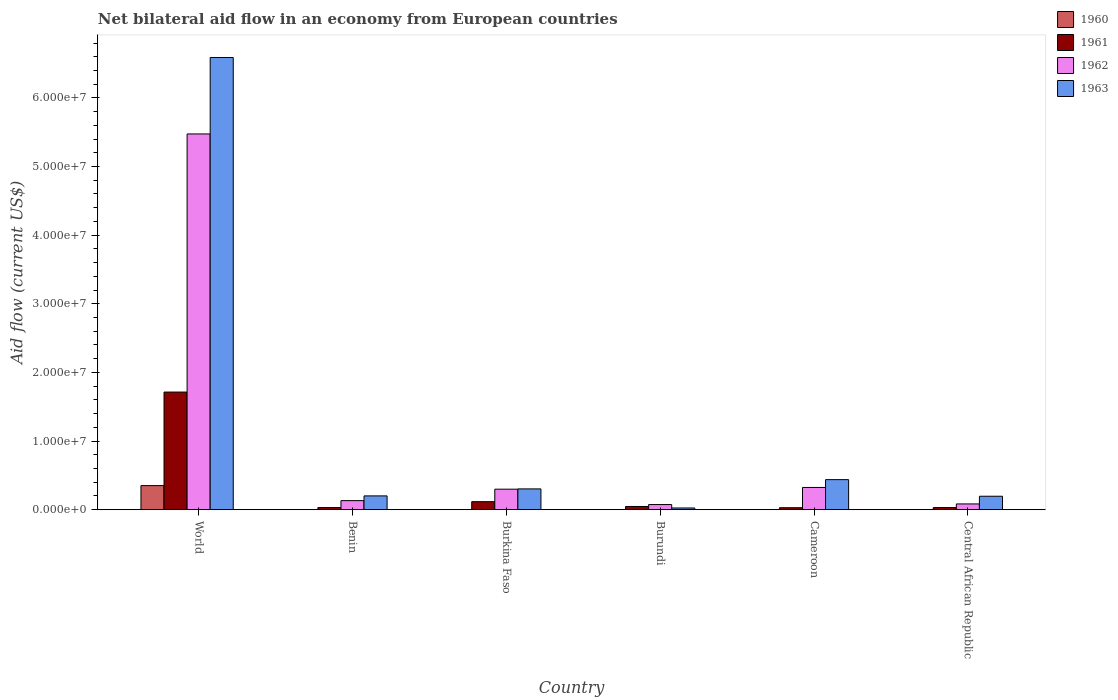How many groups of bars are there?
Give a very brief answer. 6. Are the number of bars per tick equal to the number of legend labels?
Offer a very short reply. Yes. Are the number of bars on each tick of the X-axis equal?
Your answer should be very brief. Yes. What is the label of the 6th group of bars from the left?
Your answer should be compact. Central African Republic. What is the net bilateral aid flow in 1963 in Burkina Faso?
Ensure brevity in your answer.  3.03e+06. Across all countries, what is the maximum net bilateral aid flow in 1963?
Provide a succinct answer. 6.59e+07. Across all countries, what is the minimum net bilateral aid flow in 1963?
Give a very brief answer. 2.50e+05. In which country was the net bilateral aid flow in 1960 minimum?
Offer a very short reply. Benin. What is the total net bilateral aid flow in 1962 in the graph?
Provide a short and direct response. 6.39e+07. What is the difference between the net bilateral aid flow in 1963 in Cameroon and that in Central African Republic?
Offer a very short reply. 2.42e+06. What is the difference between the net bilateral aid flow in 1961 in Cameroon and the net bilateral aid flow in 1963 in Central African Republic?
Your answer should be very brief. -1.67e+06. What is the average net bilateral aid flow in 1960 per country?
Your response must be concise. 5.97e+05. In how many countries, is the net bilateral aid flow in 1960 greater than 66000000 US$?
Provide a short and direct response. 0. Is the net bilateral aid flow in 1963 in Burkina Faso less than that in Central African Republic?
Your answer should be compact. No. What is the difference between the highest and the second highest net bilateral aid flow in 1963?
Offer a very short reply. 6.15e+07. What is the difference between the highest and the lowest net bilateral aid flow in 1960?
Give a very brief answer. 3.50e+06. Is the sum of the net bilateral aid flow in 1960 in Cameroon and Central African Republic greater than the maximum net bilateral aid flow in 1961 across all countries?
Your response must be concise. No. Is it the case that in every country, the sum of the net bilateral aid flow in 1963 and net bilateral aid flow in 1961 is greater than the sum of net bilateral aid flow in 1962 and net bilateral aid flow in 1960?
Provide a succinct answer. No. What is the difference between two consecutive major ticks on the Y-axis?
Your answer should be compact. 1.00e+07. Are the values on the major ticks of Y-axis written in scientific E-notation?
Your answer should be compact. Yes. Does the graph contain grids?
Your answer should be compact. No. Where does the legend appear in the graph?
Keep it short and to the point. Top right. How many legend labels are there?
Your answer should be compact. 4. How are the legend labels stacked?
Your response must be concise. Vertical. What is the title of the graph?
Ensure brevity in your answer.  Net bilateral aid flow in an economy from European countries. Does "1963" appear as one of the legend labels in the graph?
Keep it short and to the point. Yes. What is the label or title of the X-axis?
Offer a terse response. Country. What is the label or title of the Y-axis?
Ensure brevity in your answer.  Aid flow (current US$). What is the Aid flow (current US$) in 1960 in World?
Your answer should be compact. 3.51e+06. What is the Aid flow (current US$) in 1961 in World?
Provide a short and direct response. 1.71e+07. What is the Aid flow (current US$) in 1962 in World?
Ensure brevity in your answer.  5.48e+07. What is the Aid flow (current US$) in 1963 in World?
Provide a succinct answer. 6.59e+07. What is the Aid flow (current US$) of 1960 in Benin?
Provide a short and direct response. 10000. What is the Aid flow (current US$) in 1961 in Benin?
Offer a very short reply. 3.10e+05. What is the Aid flow (current US$) of 1962 in Benin?
Offer a very short reply. 1.32e+06. What is the Aid flow (current US$) in 1963 in Benin?
Offer a terse response. 2.01e+06. What is the Aid flow (current US$) in 1960 in Burkina Faso?
Offer a very short reply. 10000. What is the Aid flow (current US$) in 1961 in Burkina Faso?
Keep it short and to the point. 1.17e+06. What is the Aid flow (current US$) of 1962 in Burkina Faso?
Ensure brevity in your answer.  2.99e+06. What is the Aid flow (current US$) in 1963 in Burkina Faso?
Your response must be concise. 3.03e+06. What is the Aid flow (current US$) in 1961 in Burundi?
Make the answer very short. 4.70e+05. What is the Aid flow (current US$) in 1962 in Burundi?
Your response must be concise. 7.50e+05. What is the Aid flow (current US$) of 1963 in Burundi?
Provide a short and direct response. 2.50e+05. What is the Aid flow (current US$) in 1960 in Cameroon?
Keep it short and to the point. 2.00e+04. What is the Aid flow (current US$) of 1962 in Cameroon?
Give a very brief answer. 3.24e+06. What is the Aid flow (current US$) in 1963 in Cameroon?
Make the answer very short. 4.38e+06. What is the Aid flow (current US$) of 1961 in Central African Republic?
Ensure brevity in your answer.  3.10e+05. What is the Aid flow (current US$) of 1962 in Central African Republic?
Your response must be concise. 8.40e+05. What is the Aid flow (current US$) in 1963 in Central African Republic?
Your response must be concise. 1.96e+06. Across all countries, what is the maximum Aid flow (current US$) in 1960?
Your answer should be very brief. 3.51e+06. Across all countries, what is the maximum Aid flow (current US$) in 1961?
Your answer should be very brief. 1.71e+07. Across all countries, what is the maximum Aid flow (current US$) in 1962?
Offer a terse response. 5.48e+07. Across all countries, what is the maximum Aid flow (current US$) of 1963?
Make the answer very short. 6.59e+07. Across all countries, what is the minimum Aid flow (current US$) in 1960?
Provide a succinct answer. 10000. Across all countries, what is the minimum Aid flow (current US$) in 1961?
Your response must be concise. 2.90e+05. Across all countries, what is the minimum Aid flow (current US$) of 1962?
Your answer should be very brief. 7.50e+05. Across all countries, what is the minimum Aid flow (current US$) in 1963?
Provide a succinct answer. 2.50e+05. What is the total Aid flow (current US$) in 1960 in the graph?
Give a very brief answer. 3.58e+06. What is the total Aid flow (current US$) in 1961 in the graph?
Your answer should be very brief. 1.97e+07. What is the total Aid flow (current US$) in 1962 in the graph?
Ensure brevity in your answer.  6.39e+07. What is the total Aid flow (current US$) of 1963 in the graph?
Your response must be concise. 7.75e+07. What is the difference between the Aid flow (current US$) of 1960 in World and that in Benin?
Offer a terse response. 3.50e+06. What is the difference between the Aid flow (current US$) of 1961 in World and that in Benin?
Your response must be concise. 1.68e+07. What is the difference between the Aid flow (current US$) of 1962 in World and that in Benin?
Offer a very short reply. 5.34e+07. What is the difference between the Aid flow (current US$) of 1963 in World and that in Benin?
Provide a short and direct response. 6.39e+07. What is the difference between the Aid flow (current US$) in 1960 in World and that in Burkina Faso?
Provide a succinct answer. 3.50e+06. What is the difference between the Aid flow (current US$) in 1961 in World and that in Burkina Faso?
Ensure brevity in your answer.  1.60e+07. What is the difference between the Aid flow (current US$) in 1962 in World and that in Burkina Faso?
Ensure brevity in your answer.  5.18e+07. What is the difference between the Aid flow (current US$) in 1963 in World and that in Burkina Faso?
Your response must be concise. 6.29e+07. What is the difference between the Aid flow (current US$) in 1960 in World and that in Burundi?
Offer a terse response. 3.50e+06. What is the difference between the Aid flow (current US$) of 1961 in World and that in Burundi?
Ensure brevity in your answer.  1.67e+07. What is the difference between the Aid flow (current US$) in 1962 in World and that in Burundi?
Make the answer very short. 5.40e+07. What is the difference between the Aid flow (current US$) in 1963 in World and that in Burundi?
Offer a very short reply. 6.56e+07. What is the difference between the Aid flow (current US$) in 1960 in World and that in Cameroon?
Keep it short and to the point. 3.49e+06. What is the difference between the Aid flow (current US$) of 1961 in World and that in Cameroon?
Keep it short and to the point. 1.68e+07. What is the difference between the Aid flow (current US$) in 1962 in World and that in Cameroon?
Offer a very short reply. 5.15e+07. What is the difference between the Aid flow (current US$) of 1963 in World and that in Cameroon?
Offer a terse response. 6.15e+07. What is the difference between the Aid flow (current US$) of 1960 in World and that in Central African Republic?
Your response must be concise. 3.49e+06. What is the difference between the Aid flow (current US$) of 1961 in World and that in Central African Republic?
Your answer should be compact. 1.68e+07. What is the difference between the Aid flow (current US$) in 1962 in World and that in Central African Republic?
Offer a terse response. 5.39e+07. What is the difference between the Aid flow (current US$) in 1963 in World and that in Central African Republic?
Your response must be concise. 6.39e+07. What is the difference between the Aid flow (current US$) in 1961 in Benin and that in Burkina Faso?
Your response must be concise. -8.60e+05. What is the difference between the Aid flow (current US$) in 1962 in Benin and that in Burkina Faso?
Provide a short and direct response. -1.67e+06. What is the difference between the Aid flow (current US$) of 1963 in Benin and that in Burkina Faso?
Make the answer very short. -1.02e+06. What is the difference between the Aid flow (current US$) in 1960 in Benin and that in Burundi?
Your answer should be compact. 0. What is the difference between the Aid flow (current US$) of 1962 in Benin and that in Burundi?
Ensure brevity in your answer.  5.70e+05. What is the difference between the Aid flow (current US$) in 1963 in Benin and that in Burundi?
Offer a terse response. 1.76e+06. What is the difference between the Aid flow (current US$) in 1960 in Benin and that in Cameroon?
Make the answer very short. -10000. What is the difference between the Aid flow (current US$) in 1962 in Benin and that in Cameroon?
Offer a very short reply. -1.92e+06. What is the difference between the Aid flow (current US$) of 1963 in Benin and that in Cameroon?
Offer a terse response. -2.37e+06. What is the difference between the Aid flow (current US$) of 1960 in Burkina Faso and that in Burundi?
Your answer should be compact. 0. What is the difference between the Aid flow (current US$) of 1962 in Burkina Faso and that in Burundi?
Your answer should be very brief. 2.24e+06. What is the difference between the Aid flow (current US$) of 1963 in Burkina Faso and that in Burundi?
Keep it short and to the point. 2.78e+06. What is the difference between the Aid flow (current US$) in 1961 in Burkina Faso and that in Cameroon?
Provide a succinct answer. 8.80e+05. What is the difference between the Aid flow (current US$) of 1963 in Burkina Faso and that in Cameroon?
Offer a very short reply. -1.35e+06. What is the difference between the Aid flow (current US$) of 1961 in Burkina Faso and that in Central African Republic?
Provide a short and direct response. 8.60e+05. What is the difference between the Aid flow (current US$) in 1962 in Burkina Faso and that in Central African Republic?
Offer a very short reply. 2.15e+06. What is the difference between the Aid flow (current US$) in 1963 in Burkina Faso and that in Central African Republic?
Offer a terse response. 1.07e+06. What is the difference between the Aid flow (current US$) of 1960 in Burundi and that in Cameroon?
Your response must be concise. -10000. What is the difference between the Aid flow (current US$) in 1961 in Burundi and that in Cameroon?
Provide a succinct answer. 1.80e+05. What is the difference between the Aid flow (current US$) of 1962 in Burundi and that in Cameroon?
Offer a terse response. -2.49e+06. What is the difference between the Aid flow (current US$) of 1963 in Burundi and that in Cameroon?
Offer a terse response. -4.13e+06. What is the difference between the Aid flow (current US$) in 1960 in Burundi and that in Central African Republic?
Your answer should be very brief. -10000. What is the difference between the Aid flow (current US$) in 1961 in Burundi and that in Central African Republic?
Offer a very short reply. 1.60e+05. What is the difference between the Aid flow (current US$) of 1963 in Burundi and that in Central African Republic?
Make the answer very short. -1.71e+06. What is the difference between the Aid flow (current US$) of 1961 in Cameroon and that in Central African Republic?
Your answer should be very brief. -2.00e+04. What is the difference between the Aid flow (current US$) in 1962 in Cameroon and that in Central African Republic?
Provide a short and direct response. 2.40e+06. What is the difference between the Aid flow (current US$) of 1963 in Cameroon and that in Central African Republic?
Your answer should be very brief. 2.42e+06. What is the difference between the Aid flow (current US$) of 1960 in World and the Aid flow (current US$) of 1961 in Benin?
Keep it short and to the point. 3.20e+06. What is the difference between the Aid flow (current US$) in 1960 in World and the Aid flow (current US$) in 1962 in Benin?
Give a very brief answer. 2.19e+06. What is the difference between the Aid flow (current US$) in 1960 in World and the Aid flow (current US$) in 1963 in Benin?
Your answer should be very brief. 1.50e+06. What is the difference between the Aid flow (current US$) in 1961 in World and the Aid flow (current US$) in 1962 in Benin?
Your answer should be very brief. 1.58e+07. What is the difference between the Aid flow (current US$) of 1961 in World and the Aid flow (current US$) of 1963 in Benin?
Make the answer very short. 1.51e+07. What is the difference between the Aid flow (current US$) of 1962 in World and the Aid flow (current US$) of 1963 in Benin?
Your answer should be compact. 5.27e+07. What is the difference between the Aid flow (current US$) in 1960 in World and the Aid flow (current US$) in 1961 in Burkina Faso?
Your answer should be compact. 2.34e+06. What is the difference between the Aid flow (current US$) in 1960 in World and the Aid flow (current US$) in 1962 in Burkina Faso?
Make the answer very short. 5.20e+05. What is the difference between the Aid flow (current US$) in 1961 in World and the Aid flow (current US$) in 1962 in Burkina Faso?
Offer a very short reply. 1.42e+07. What is the difference between the Aid flow (current US$) of 1961 in World and the Aid flow (current US$) of 1963 in Burkina Faso?
Make the answer very short. 1.41e+07. What is the difference between the Aid flow (current US$) of 1962 in World and the Aid flow (current US$) of 1963 in Burkina Faso?
Make the answer very short. 5.17e+07. What is the difference between the Aid flow (current US$) in 1960 in World and the Aid flow (current US$) in 1961 in Burundi?
Keep it short and to the point. 3.04e+06. What is the difference between the Aid flow (current US$) of 1960 in World and the Aid flow (current US$) of 1962 in Burundi?
Provide a short and direct response. 2.76e+06. What is the difference between the Aid flow (current US$) in 1960 in World and the Aid flow (current US$) in 1963 in Burundi?
Ensure brevity in your answer.  3.26e+06. What is the difference between the Aid flow (current US$) in 1961 in World and the Aid flow (current US$) in 1962 in Burundi?
Offer a very short reply. 1.64e+07. What is the difference between the Aid flow (current US$) of 1961 in World and the Aid flow (current US$) of 1963 in Burundi?
Your response must be concise. 1.69e+07. What is the difference between the Aid flow (current US$) of 1962 in World and the Aid flow (current US$) of 1963 in Burundi?
Your response must be concise. 5.45e+07. What is the difference between the Aid flow (current US$) in 1960 in World and the Aid flow (current US$) in 1961 in Cameroon?
Make the answer very short. 3.22e+06. What is the difference between the Aid flow (current US$) of 1960 in World and the Aid flow (current US$) of 1962 in Cameroon?
Provide a succinct answer. 2.70e+05. What is the difference between the Aid flow (current US$) in 1960 in World and the Aid flow (current US$) in 1963 in Cameroon?
Offer a terse response. -8.70e+05. What is the difference between the Aid flow (current US$) in 1961 in World and the Aid flow (current US$) in 1962 in Cameroon?
Your response must be concise. 1.39e+07. What is the difference between the Aid flow (current US$) of 1961 in World and the Aid flow (current US$) of 1963 in Cameroon?
Keep it short and to the point. 1.28e+07. What is the difference between the Aid flow (current US$) in 1962 in World and the Aid flow (current US$) in 1963 in Cameroon?
Ensure brevity in your answer.  5.04e+07. What is the difference between the Aid flow (current US$) in 1960 in World and the Aid flow (current US$) in 1961 in Central African Republic?
Offer a very short reply. 3.20e+06. What is the difference between the Aid flow (current US$) of 1960 in World and the Aid flow (current US$) of 1962 in Central African Republic?
Offer a terse response. 2.67e+06. What is the difference between the Aid flow (current US$) of 1960 in World and the Aid flow (current US$) of 1963 in Central African Republic?
Your response must be concise. 1.55e+06. What is the difference between the Aid flow (current US$) of 1961 in World and the Aid flow (current US$) of 1962 in Central African Republic?
Provide a succinct answer. 1.63e+07. What is the difference between the Aid flow (current US$) in 1961 in World and the Aid flow (current US$) in 1963 in Central African Republic?
Offer a very short reply. 1.52e+07. What is the difference between the Aid flow (current US$) in 1962 in World and the Aid flow (current US$) in 1963 in Central African Republic?
Offer a very short reply. 5.28e+07. What is the difference between the Aid flow (current US$) in 1960 in Benin and the Aid flow (current US$) in 1961 in Burkina Faso?
Your answer should be compact. -1.16e+06. What is the difference between the Aid flow (current US$) in 1960 in Benin and the Aid flow (current US$) in 1962 in Burkina Faso?
Your answer should be compact. -2.98e+06. What is the difference between the Aid flow (current US$) in 1960 in Benin and the Aid flow (current US$) in 1963 in Burkina Faso?
Your answer should be compact. -3.02e+06. What is the difference between the Aid flow (current US$) of 1961 in Benin and the Aid flow (current US$) of 1962 in Burkina Faso?
Keep it short and to the point. -2.68e+06. What is the difference between the Aid flow (current US$) in 1961 in Benin and the Aid flow (current US$) in 1963 in Burkina Faso?
Offer a very short reply. -2.72e+06. What is the difference between the Aid flow (current US$) in 1962 in Benin and the Aid flow (current US$) in 1963 in Burkina Faso?
Your answer should be very brief. -1.71e+06. What is the difference between the Aid flow (current US$) of 1960 in Benin and the Aid flow (current US$) of 1961 in Burundi?
Your answer should be compact. -4.60e+05. What is the difference between the Aid flow (current US$) of 1960 in Benin and the Aid flow (current US$) of 1962 in Burundi?
Keep it short and to the point. -7.40e+05. What is the difference between the Aid flow (current US$) in 1961 in Benin and the Aid flow (current US$) in 1962 in Burundi?
Provide a succinct answer. -4.40e+05. What is the difference between the Aid flow (current US$) in 1962 in Benin and the Aid flow (current US$) in 1963 in Burundi?
Give a very brief answer. 1.07e+06. What is the difference between the Aid flow (current US$) of 1960 in Benin and the Aid flow (current US$) of 1961 in Cameroon?
Ensure brevity in your answer.  -2.80e+05. What is the difference between the Aid flow (current US$) of 1960 in Benin and the Aid flow (current US$) of 1962 in Cameroon?
Keep it short and to the point. -3.23e+06. What is the difference between the Aid flow (current US$) in 1960 in Benin and the Aid flow (current US$) in 1963 in Cameroon?
Give a very brief answer. -4.37e+06. What is the difference between the Aid flow (current US$) in 1961 in Benin and the Aid flow (current US$) in 1962 in Cameroon?
Offer a terse response. -2.93e+06. What is the difference between the Aid flow (current US$) in 1961 in Benin and the Aid flow (current US$) in 1963 in Cameroon?
Give a very brief answer. -4.07e+06. What is the difference between the Aid flow (current US$) in 1962 in Benin and the Aid flow (current US$) in 1963 in Cameroon?
Your response must be concise. -3.06e+06. What is the difference between the Aid flow (current US$) of 1960 in Benin and the Aid flow (current US$) of 1962 in Central African Republic?
Provide a short and direct response. -8.30e+05. What is the difference between the Aid flow (current US$) of 1960 in Benin and the Aid flow (current US$) of 1963 in Central African Republic?
Your answer should be very brief. -1.95e+06. What is the difference between the Aid flow (current US$) of 1961 in Benin and the Aid flow (current US$) of 1962 in Central African Republic?
Your response must be concise. -5.30e+05. What is the difference between the Aid flow (current US$) in 1961 in Benin and the Aid flow (current US$) in 1963 in Central African Republic?
Provide a succinct answer. -1.65e+06. What is the difference between the Aid flow (current US$) in 1962 in Benin and the Aid flow (current US$) in 1963 in Central African Republic?
Your answer should be compact. -6.40e+05. What is the difference between the Aid flow (current US$) in 1960 in Burkina Faso and the Aid flow (current US$) in 1961 in Burundi?
Offer a terse response. -4.60e+05. What is the difference between the Aid flow (current US$) of 1960 in Burkina Faso and the Aid flow (current US$) of 1962 in Burundi?
Offer a terse response. -7.40e+05. What is the difference between the Aid flow (current US$) in 1960 in Burkina Faso and the Aid flow (current US$) in 1963 in Burundi?
Ensure brevity in your answer.  -2.40e+05. What is the difference between the Aid flow (current US$) of 1961 in Burkina Faso and the Aid flow (current US$) of 1963 in Burundi?
Offer a terse response. 9.20e+05. What is the difference between the Aid flow (current US$) of 1962 in Burkina Faso and the Aid flow (current US$) of 1963 in Burundi?
Offer a very short reply. 2.74e+06. What is the difference between the Aid flow (current US$) in 1960 in Burkina Faso and the Aid flow (current US$) in 1961 in Cameroon?
Your response must be concise. -2.80e+05. What is the difference between the Aid flow (current US$) in 1960 in Burkina Faso and the Aid flow (current US$) in 1962 in Cameroon?
Provide a short and direct response. -3.23e+06. What is the difference between the Aid flow (current US$) of 1960 in Burkina Faso and the Aid flow (current US$) of 1963 in Cameroon?
Ensure brevity in your answer.  -4.37e+06. What is the difference between the Aid flow (current US$) of 1961 in Burkina Faso and the Aid flow (current US$) of 1962 in Cameroon?
Make the answer very short. -2.07e+06. What is the difference between the Aid flow (current US$) of 1961 in Burkina Faso and the Aid flow (current US$) of 1963 in Cameroon?
Give a very brief answer. -3.21e+06. What is the difference between the Aid flow (current US$) in 1962 in Burkina Faso and the Aid flow (current US$) in 1963 in Cameroon?
Keep it short and to the point. -1.39e+06. What is the difference between the Aid flow (current US$) in 1960 in Burkina Faso and the Aid flow (current US$) in 1961 in Central African Republic?
Give a very brief answer. -3.00e+05. What is the difference between the Aid flow (current US$) in 1960 in Burkina Faso and the Aid flow (current US$) in 1962 in Central African Republic?
Keep it short and to the point. -8.30e+05. What is the difference between the Aid flow (current US$) of 1960 in Burkina Faso and the Aid flow (current US$) of 1963 in Central African Republic?
Offer a terse response. -1.95e+06. What is the difference between the Aid flow (current US$) of 1961 in Burkina Faso and the Aid flow (current US$) of 1963 in Central African Republic?
Ensure brevity in your answer.  -7.90e+05. What is the difference between the Aid flow (current US$) of 1962 in Burkina Faso and the Aid flow (current US$) of 1963 in Central African Republic?
Offer a terse response. 1.03e+06. What is the difference between the Aid flow (current US$) of 1960 in Burundi and the Aid flow (current US$) of 1961 in Cameroon?
Your answer should be very brief. -2.80e+05. What is the difference between the Aid flow (current US$) in 1960 in Burundi and the Aid flow (current US$) in 1962 in Cameroon?
Keep it short and to the point. -3.23e+06. What is the difference between the Aid flow (current US$) of 1960 in Burundi and the Aid flow (current US$) of 1963 in Cameroon?
Your answer should be compact. -4.37e+06. What is the difference between the Aid flow (current US$) in 1961 in Burundi and the Aid flow (current US$) in 1962 in Cameroon?
Offer a terse response. -2.77e+06. What is the difference between the Aid flow (current US$) in 1961 in Burundi and the Aid flow (current US$) in 1963 in Cameroon?
Provide a succinct answer. -3.91e+06. What is the difference between the Aid flow (current US$) in 1962 in Burundi and the Aid flow (current US$) in 1963 in Cameroon?
Make the answer very short. -3.63e+06. What is the difference between the Aid flow (current US$) in 1960 in Burundi and the Aid flow (current US$) in 1962 in Central African Republic?
Offer a very short reply. -8.30e+05. What is the difference between the Aid flow (current US$) of 1960 in Burundi and the Aid flow (current US$) of 1963 in Central African Republic?
Provide a succinct answer. -1.95e+06. What is the difference between the Aid flow (current US$) in 1961 in Burundi and the Aid flow (current US$) in 1962 in Central African Republic?
Your answer should be compact. -3.70e+05. What is the difference between the Aid flow (current US$) of 1961 in Burundi and the Aid flow (current US$) of 1963 in Central African Republic?
Your answer should be very brief. -1.49e+06. What is the difference between the Aid flow (current US$) in 1962 in Burundi and the Aid flow (current US$) in 1963 in Central African Republic?
Keep it short and to the point. -1.21e+06. What is the difference between the Aid flow (current US$) in 1960 in Cameroon and the Aid flow (current US$) in 1962 in Central African Republic?
Offer a terse response. -8.20e+05. What is the difference between the Aid flow (current US$) in 1960 in Cameroon and the Aid flow (current US$) in 1963 in Central African Republic?
Your answer should be compact. -1.94e+06. What is the difference between the Aid flow (current US$) in 1961 in Cameroon and the Aid flow (current US$) in 1962 in Central African Republic?
Offer a very short reply. -5.50e+05. What is the difference between the Aid flow (current US$) of 1961 in Cameroon and the Aid flow (current US$) of 1963 in Central African Republic?
Your response must be concise. -1.67e+06. What is the difference between the Aid flow (current US$) in 1962 in Cameroon and the Aid flow (current US$) in 1963 in Central African Republic?
Your response must be concise. 1.28e+06. What is the average Aid flow (current US$) of 1960 per country?
Keep it short and to the point. 5.97e+05. What is the average Aid flow (current US$) of 1961 per country?
Your response must be concise. 3.28e+06. What is the average Aid flow (current US$) in 1962 per country?
Your answer should be very brief. 1.06e+07. What is the average Aid flow (current US$) in 1963 per country?
Provide a succinct answer. 1.29e+07. What is the difference between the Aid flow (current US$) in 1960 and Aid flow (current US$) in 1961 in World?
Your answer should be very brief. -1.36e+07. What is the difference between the Aid flow (current US$) in 1960 and Aid flow (current US$) in 1962 in World?
Your answer should be compact. -5.12e+07. What is the difference between the Aid flow (current US$) of 1960 and Aid flow (current US$) of 1963 in World?
Keep it short and to the point. -6.24e+07. What is the difference between the Aid flow (current US$) of 1961 and Aid flow (current US$) of 1962 in World?
Your response must be concise. -3.76e+07. What is the difference between the Aid flow (current US$) of 1961 and Aid flow (current US$) of 1963 in World?
Provide a succinct answer. -4.88e+07. What is the difference between the Aid flow (current US$) in 1962 and Aid flow (current US$) in 1963 in World?
Offer a very short reply. -1.11e+07. What is the difference between the Aid flow (current US$) in 1960 and Aid flow (current US$) in 1961 in Benin?
Your answer should be very brief. -3.00e+05. What is the difference between the Aid flow (current US$) of 1960 and Aid flow (current US$) of 1962 in Benin?
Your response must be concise. -1.31e+06. What is the difference between the Aid flow (current US$) in 1961 and Aid flow (current US$) in 1962 in Benin?
Offer a very short reply. -1.01e+06. What is the difference between the Aid flow (current US$) of 1961 and Aid flow (current US$) of 1963 in Benin?
Ensure brevity in your answer.  -1.70e+06. What is the difference between the Aid flow (current US$) of 1962 and Aid flow (current US$) of 1963 in Benin?
Offer a terse response. -6.90e+05. What is the difference between the Aid flow (current US$) of 1960 and Aid flow (current US$) of 1961 in Burkina Faso?
Provide a succinct answer. -1.16e+06. What is the difference between the Aid flow (current US$) in 1960 and Aid flow (current US$) in 1962 in Burkina Faso?
Make the answer very short. -2.98e+06. What is the difference between the Aid flow (current US$) in 1960 and Aid flow (current US$) in 1963 in Burkina Faso?
Make the answer very short. -3.02e+06. What is the difference between the Aid flow (current US$) of 1961 and Aid flow (current US$) of 1962 in Burkina Faso?
Your response must be concise. -1.82e+06. What is the difference between the Aid flow (current US$) of 1961 and Aid flow (current US$) of 1963 in Burkina Faso?
Ensure brevity in your answer.  -1.86e+06. What is the difference between the Aid flow (current US$) of 1960 and Aid flow (current US$) of 1961 in Burundi?
Offer a terse response. -4.60e+05. What is the difference between the Aid flow (current US$) of 1960 and Aid flow (current US$) of 1962 in Burundi?
Give a very brief answer. -7.40e+05. What is the difference between the Aid flow (current US$) of 1961 and Aid flow (current US$) of 1962 in Burundi?
Offer a terse response. -2.80e+05. What is the difference between the Aid flow (current US$) in 1961 and Aid flow (current US$) in 1963 in Burundi?
Provide a short and direct response. 2.20e+05. What is the difference between the Aid flow (current US$) of 1962 and Aid flow (current US$) of 1963 in Burundi?
Offer a very short reply. 5.00e+05. What is the difference between the Aid flow (current US$) in 1960 and Aid flow (current US$) in 1961 in Cameroon?
Provide a succinct answer. -2.70e+05. What is the difference between the Aid flow (current US$) in 1960 and Aid flow (current US$) in 1962 in Cameroon?
Your response must be concise. -3.22e+06. What is the difference between the Aid flow (current US$) in 1960 and Aid flow (current US$) in 1963 in Cameroon?
Keep it short and to the point. -4.36e+06. What is the difference between the Aid flow (current US$) in 1961 and Aid flow (current US$) in 1962 in Cameroon?
Keep it short and to the point. -2.95e+06. What is the difference between the Aid flow (current US$) in 1961 and Aid flow (current US$) in 1963 in Cameroon?
Make the answer very short. -4.09e+06. What is the difference between the Aid flow (current US$) of 1962 and Aid flow (current US$) of 1963 in Cameroon?
Offer a very short reply. -1.14e+06. What is the difference between the Aid flow (current US$) in 1960 and Aid flow (current US$) in 1961 in Central African Republic?
Offer a terse response. -2.90e+05. What is the difference between the Aid flow (current US$) in 1960 and Aid flow (current US$) in 1962 in Central African Republic?
Offer a terse response. -8.20e+05. What is the difference between the Aid flow (current US$) in 1960 and Aid flow (current US$) in 1963 in Central African Republic?
Provide a succinct answer. -1.94e+06. What is the difference between the Aid flow (current US$) of 1961 and Aid flow (current US$) of 1962 in Central African Republic?
Offer a very short reply. -5.30e+05. What is the difference between the Aid flow (current US$) of 1961 and Aid flow (current US$) of 1963 in Central African Republic?
Your response must be concise. -1.65e+06. What is the difference between the Aid flow (current US$) of 1962 and Aid flow (current US$) of 1963 in Central African Republic?
Provide a short and direct response. -1.12e+06. What is the ratio of the Aid flow (current US$) in 1960 in World to that in Benin?
Give a very brief answer. 351. What is the ratio of the Aid flow (current US$) in 1961 in World to that in Benin?
Your answer should be compact. 55.29. What is the ratio of the Aid flow (current US$) of 1962 in World to that in Benin?
Your answer should be compact. 41.48. What is the ratio of the Aid flow (current US$) of 1963 in World to that in Benin?
Your response must be concise. 32.78. What is the ratio of the Aid flow (current US$) in 1960 in World to that in Burkina Faso?
Your answer should be very brief. 351. What is the ratio of the Aid flow (current US$) of 1961 in World to that in Burkina Faso?
Make the answer very short. 14.65. What is the ratio of the Aid flow (current US$) in 1962 in World to that in Burkina Faso?
Keep it short and to the point. 18.31. What is the ratio of the Aid flow (current US$) in 1963 in World to that in Burkina Faso?
Offer a very short reply. 21.75. What is the ratio of the Aid flow (current US$) in 1960 in World to that in Burundi?
Offer a very short reply. 351. What is the ratio of the Aid flow (current US$) in 1961 in World to that in Burundi?
Keep it short and to the point. 36.47. What is the ratio of the Aid flow (current US$) of 1962 in World to that in Burundi?
Your answer should be very brief. 73. What is the ratio of the Aid flow (current US$) of 1963 in World to that in Burundi?
Your answer should be very brief. 263.56. What is the ratio of the Aid flow (current US$) in 1960 in World to that in Cameroon?
Keep it short and to the point. 175.5. What is the ratio of the Aid flow (current US$) in 1961 in World to that in Cameroon?
Offer a very short reply. 59.1. What is the ratio of the Aid flow (current US$) in 1962 in World to that in Cameroon?
Give a very brief answer. 16.9. What is the ratio of the Aid flow (current US$) in 1963 in World to that in Cameroon?
Keep it short and to the point. 15.04. What is the ratio of the Aid flow (current US$) in 1960 in World to that in Central African Republic?
Keep it short and to the point. 175.5. What is the ratio of the Aid flow (current US$) of 1961 in World to that in Central African Republic?
Your response must be concise. 55.29. What is the ratio of the Aid flow (current US$) in 1962 in World to that in Central African Republic?
Your answer should be compact. 65.18. What is the ratio of the Aid flow (current US$) of 1963 in World to that in Central African Republic?
Offer a terse response. 33.62. What is the ratio of the Aid flow (current US$) in 1961 in Benin to that in Burkina Faso?
Ensure brevity in your answer.  0.27. What is the ratio of the Aid flow (current US$) in 1962 in Benin to that in Burkina Faso?
Keep it short and to the point. 0.44. What is the ratio of the Aid flow (current US$) of 1963 in Benin to that in Burkina Faso?
Provide a short and direct response. 0.66. What is the ratio of the Aid flow (current US$) in 1960 in Benin to that in Burundi?
Give a very brief answer. 1. What is the ratio of the Aid flow (current US$) of 1961 in Benin to that in Burundi?
Provide a succinct answer. 0.66. What is the ratio of the Aid flow (current US$) of 1962 in Benin to that in Burundi?
Ensure brevity in your answer.  1.76. What is the ratio of the Aid flow (current US$) of 1963 in Benin to that in Burundi?
Provide a short and direct response. 8.04. What is the ratio of the Aid flow (current US$) in 1960 in Benin to that in Cameroon?
Your response must be concise. 0.5. What is the ratio of the Aid flow (current US$) of 1961 in Benin to that in Cameroon?
Make the answer very short. 1.07. What is the ratio of the Aid flow (current US$) in 1962 in Benin to that in Cameroon?
Your response must be concise. 0.41. What is the ratio of the Aid flow (current US$) in 1963 in Benin to that in Cameroon?
Your response must be concise. 0.46. What is the ratio of the Aid flow (current US$) of 1960 in Benin to that in Central African Republic?
Keep it short and to the point. 0.5. What is the ratio of the Aid flow (current US$) in 1962 in Benin to that in Central African Republic?
Make the answer very short. 1.57. What is the ratio of the Aid flow (current US$) of 1963 in Benin to that in Central African Republic?
Ensure brevity in your answer.  1.03. What is the ratio of the Aid flow (current US$) of 1961 in Burkina Faso to that in Burundi?
Give a very brief answer. 2.49. What is the ratio of the Aid flow (current US$) in 1962 in Burkina Faso to that in Burundi?
Give a very brief answer. 3.99. What is the ratio of the Aid flow (current US$) of 1963 in Burkina Faso to that in Burundi?
Ensure brevity in your answer.  12.12. What is the ratio of the Aid flow (current US$) in 1961 in Burkina Faso to that in Cameroon?
Your answer should be compact. 4.03. What is the ratio of the Aid flow (current US$) in 1962 in Burkina Faso to that in Cameroon?
Provide a succinct answer. 0.92. What is the ratio of the Aid flow (current US$) in 1963 in Burkina Faso to that in Cameroon?
Provide a short and direct response. 0.69. What is the ratio of the Aid flow (current US$) of 1960 in Burkina Faso to that in Central African Republic?
Provide a short and direct response. 0.5. What is the ratio of the Aid flow (current US$) of 1961 in Burkina Faso to that in Central African Republic?
Provide a short and direct response. 3.77. What is the ratio of the Aid flow (current US$) of 1962 in Burkina Faso to that in Central African Republic?
Make the answer very short. 3.56. What is the ratio of the Aid flow (current US$) in 1963 in Burkina Faso to that in Central African Republic?
Your response must be concise. 1.55. What is the ratio of the Aid flow (current US$) of 1960 in Burundi to that in Cameroon?
Your answer should be compact. 0.5. What is the ratio of the Aid flow (current US$) of 1961 in Burundi to that in Cameroon?
Give a very brief answer. 1.62. What is the ratio of the Aid flow (current US$) of 1962 in Burundi to that in Cameroon?
Provide a short and direct response. 0.23. What is the ratio of the Aid flow (current US$) in 1963 in Burundi to that in Cameroon?
Your response must be concise. 0.06. What is the ratio of the Aid flow (current US$) in 1960 in Burundi to that in Central African Republic?
Make the answer very short. 0.5. What is the ratio of the Aid flow (current US$) of 1961 in Burundi to that in Central African Republic?
Provide a short and direct response. 1.52. What is the ratio of the Aid flow (current US$) of 1962 in Burundi to that in Central African Republic?
Provide a succinct answer. 0.89. What is the ratio of the Aid flow (current US$) in 1963 in Burundi to that in Central African Republic?
Your response must be concise. 0.13. What is the ratio of the Aid flow (current US$) of 1960 in Cameroon to that in Central African Republic?
Your response must be concise. 1. What is the ratio of the Aid flow (current US$) of 1961 in Cameroon to that in Central African Republic?
Your answer should be compact. 0.94. What is the ratio of the Aid flow (current US$) in 1962 in Cameroon to that in Central African Republic?
Keep it short and to the point. 3.86. What is the ratio of the Aid flow (current US$) in 1963 in Cameroon to that in Central African Republic?
Ensure brevity in your answer.  2.23. What is the difference between the highest and the second highest Aid flow (current US$) in 1960?
Ensure brevity in your answer.  3.49e+06. What is the difference between the highest and the second highest Aid flow (current US$) of 1961?
Give a very brief answer. 1.60e+07. What is the difference between the highest and the second highest Aid flow (current US$) in 1962?
Give a very brief answer. 5.15e+07. What is the difference between the highest and the second highest Aid flow (current US$) of 1963?
Offer a terse response. 6.15e+07. What is the difference between the highest and the lowest Aid flow (current US$) in 1960?
Offer a terse response. 3.50e+06. What is the difference between the highest and the lowest Aid flow (current US$) in 1961?
Ensure brevity in your answer.  1.68e+07. What is the difference between the highest and the lowest Aid flow (current US$) in 1962?
Provide a short and direct response. 5.40e+07. What is the difference between the highest and the lowest Aid flow (current US$) in 1963?
Keep it short and to the point. 6.56e+07. 